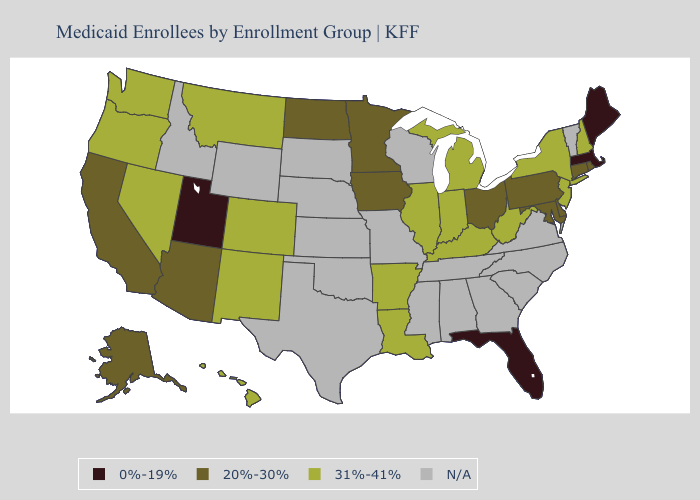Among the states that border Missouri , which have the highest value?
Give a very brief answer. Arkansas, Illinois, Kentucky. Name the states that have a value in the range N/A?
Keep it brief. Alabama, Georgia, Idaho, Kansas, Mississippi, Missouri, Nebraska, North Carolina, Oklahoma, South Carolina, South Dakota, Tennessee, Texas, Vermont, Virginia, Wisconsin, Wyoming. Among the states that border Iowa , does Minnesota have the lowest value?
Answer briefly. Yes. Does the map have missing data?
Short answer required. Yes. Name the states that have a value in the range 0%-19%?
Short answer required. Florida, Maine, Massachusetts, Utah. What is the value of Washington?
Write a very short answer. 31%-41%. Among the states that border Delaware , does New Jersey have the highest value?
Keep it brief. Yes. What is the lowest value in the West?
Keep it brief. 0%-19%. Name the states that have a value in the range 20%-30%?
Give a very brief answer. Alaska, Arizona, California, Connecticut, Delaware, Iowa, Maryland, Minnesota, North Dakota, Ohio, Pennsylvania, Rhode Island. Does Maine have the highest value in the USA?
Write a very short answer. No. Name the states that have a value in the range 31%-41%?
Give a very brief answer. Arkansas, Colorado, Hawaii, Illinois, Indiana, Kentucky, Louisiana, Michigan, Montana, Nevada, New Hampshire, New Jersey, New Mexico, New York, Oregon, Washington, West Virginia. Does the map have missing data?
Short answer required. Yes. What is the highest value in the USA?
Write a very short answer. 31%-41%. Name the states that have a value in the range 31%-41%?
Keep it brief. Arkansas, Colorado, Hawaii, Illinois, Indiana, Kentucky, Louisiana, Michigan, Montana, Nevada, New Hampshire, New Jersey, New Mexico, New York, Oregon, Washington, West Virginia. Which states have the lowest value in the USA?
Quick response, please. Florida, Maine, Massachusetts, Utah. 